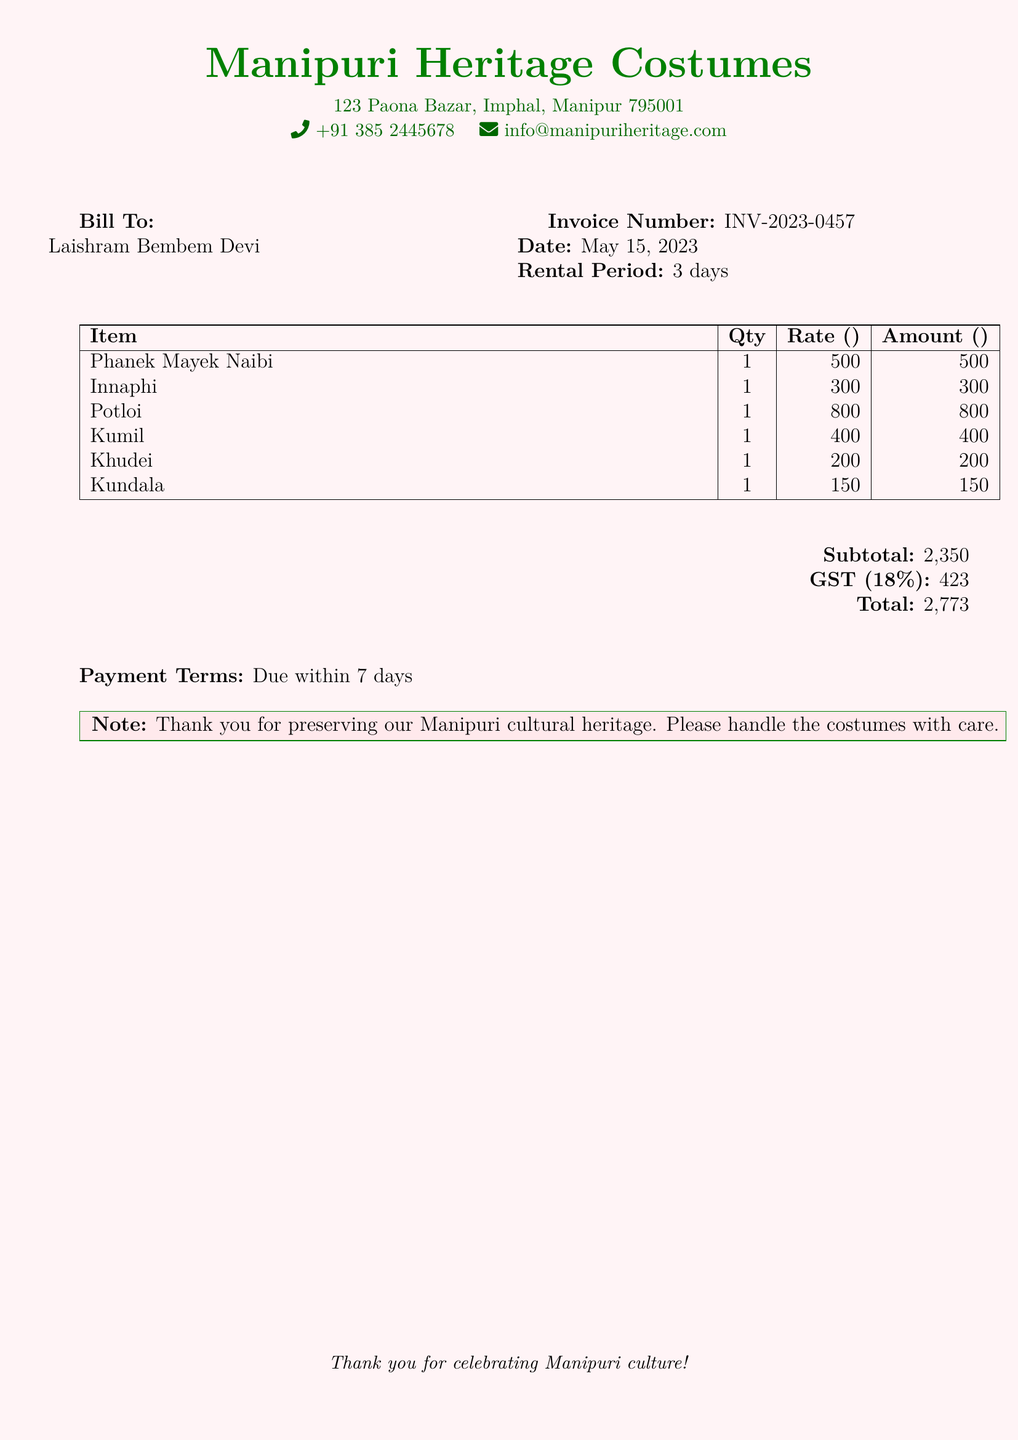What is the invoice number? The invoice number is a unique identifier for the document, found in the header section.
Answer: INV-2023-0457 What is the total amount due? The total amount due is calculated as the sum of the subtotal and GST, listed at the bottom of the document.
Answer: ₹2,773 What is the rental period? The rental period represents the duration for which the costumes are rented, stated in the document.
Answer: 3 days Who is the bill addressed to? The bill is personalized to a specific individual, mentioned in the 'Bill To' section.
Answer: Laishram Bembem Devi What is the GST percentage applied? The GST percentage indicates the tax rate applied to the billed amount, noted in the financial breakdown.
Answer: 18% What is the subtotal amount before tax? The subtotal amount is the total cost of all items listed before any additional taxes are applied.
Answer: ₹2,350 What is the note at the bottom of the document? This note expresses gratitude and a request regarding the handling of the rented items.
Answer: Thank you for preserving our Manipuri cultural heritage. Please handle the costumes with care What is the phone number listed in the header? The phone number is provided for contact purposes and is located at the top of the document.
Answer: +91 385 2445678 What color is used for the document's background? The color refers to the overall visual aesthetic of the document and is specified in the code.
Answer: Manipuri pink 